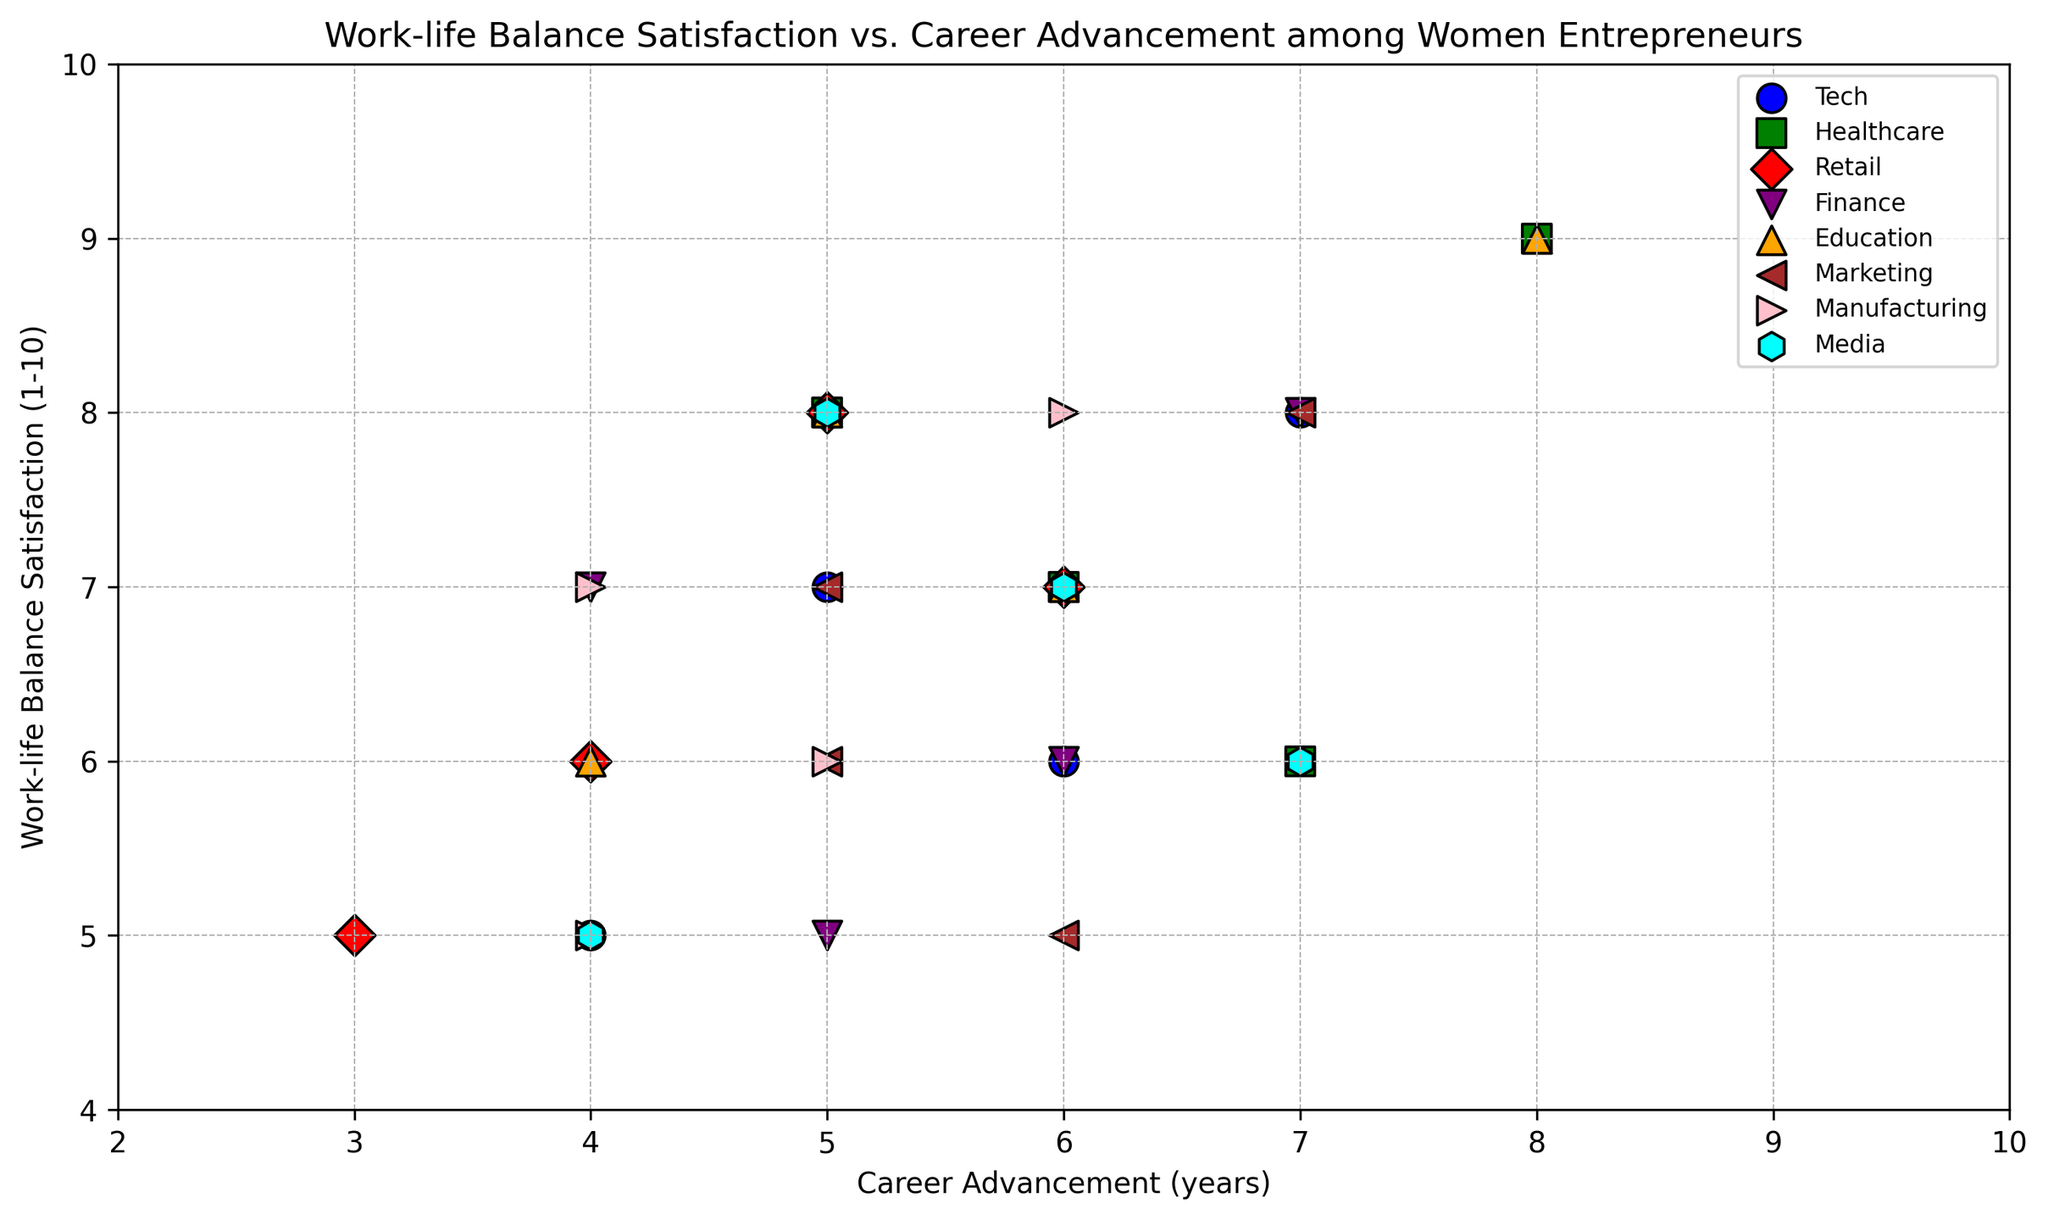Which sector has the highest average Work-life Balance Satisfaction? Calculate the average Work-life Balance Satisfaction score for each sector by summing their respective scores and dividing by the number of data points for that sector. The highest average will indicate the sector with the best work-life balance satisfaction.
Answer: Education Compare the Work-life Balance Satisfaction and Career Advancement for Tech and Media sectors. Which sector generally shows higher Work-life Balance Satisfaction with similar years of Career Advancement? Compare the scores for Work-life Balance Satisfaction between Tech and Media for similar Career Advancement years (e.g., 4, 5, 6, 7). Identify which sector consistently has higher Work-life Balance Satisfaction scores for these comparison points.
Answer: Media What is the range of Work-life Balance Satisfaction scores for the Healthcare sector? The range is calculated by subtracting the smallest value from the largest value in the Work-life Balance Satisfaction scores for Healthcare. Identify the maximum and minimum scores for Healthcare and find their difference.
Answer: 3 (9 - 6) For the Healthcare sector, what is the mean value of Career Advancement? Sum up all the values of Career Advancement for the Healthcare sector and divide by the number of data points (4 in this case). This would give you the mean value. (5 + 6 + 7 + 8) / 4 = 6.5
Answer: 6.5 In which sector is there the most variability in Work-life Balance Satisfaction, and how can you tell? Variability can be assessed by looking at the spread of the data points in the Work-life Balance Satisfaction axis. The sector with the widest spread in scores (difference between highest and lowest values) exhibits the most variability.
Answer: Retail Which two sectors have the closest experience in Career Advancement years but differ significantly in Work-life Balance Satisfaction? Identify pairs of sectors with similar average values for Career Advancement years but differing values in Work-life Balance Satisfaction. Calculate average Career Advancement and compare them.
Answer: Retail and Tech Does the Marketing sector show a trend between Work-life Balance Satisfaction and Career Advancement? Observe if there is any visible trend (e.g., increasing, decreasing, or no correlation) between the Work-life Balance Satisfaction and Career Advancement for the Marketing sector. If scores tend to increase together, it indicates a positive trend.
Answer: Slight upward trend Looking at the scatter plot, which sector has data points that are most uniformly distributed across Work-life Balance Satisfaction levels and Career Advancement years? Uniform distribution means the data points are spread out evenly without clustering. Identify which sector’s data points cover a broad range in both axes without crowding in specific areas.
Answer: Manufacturing 